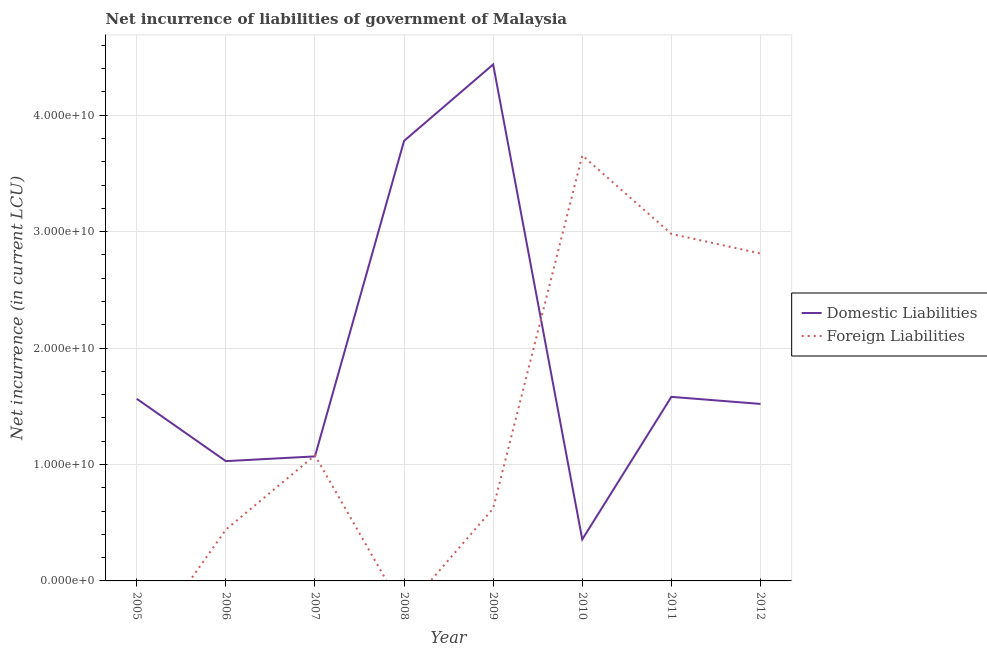How many different coloured lines are there?
Provide a succinct answer. 2. Is the number of lines equal to the number of legend labels?
Your response must be concise. No. What is the net incurrence of domestic liabilities in 2005?
Provide a short and direct response. 1.56e+1. Across all years, what is the maximum net incurrence of domestic liabilities?
Ensure brevity in your answer.  4.44e+1. Across all years, what is the minimum net incurrence of domestic liabilities?
Keep it short and to the point. 3.57e+09. What is the total net incurrence of domestic liabilities in the graph?
Ensure brevity in your answer.  1.53e+11. What is the difference between the net incurrence of domestic liabilities in 2006 and that in 2012?
Keep it short and to the point. -4.91e+09. What is the difference between the net incurrence of domestic liabilities in 2008 and the net incurrence of foreign liabilities in 2012?
Ensure brevity in your answer.  9.67e+09. What is the average net incurrence of foreign liabilities per year?
Make the answer very short. 1.45e+1. In the year 2010, what is the difference between the net incurrence of foreign liabilities and net incurrence of domestic liabilities?
Provide a short and direct response. 3.30e+1. In how many years, is the net incurrence of foreign liabilities greater than 30000000000 LCU?
Offer a terse response. 1. What is the ratio of the net incurrence of domestic liabilities in 2007 to that in 2008?
Keep it short and to the point. 0.28. Is the difference between the net incurrence of foreign liabilities in 2006 and 2012 greater than the difference between the net incurrence of domestic liabilities in 2006 and 2012?
Your response must be concise. No. What is the difference between the highest and the second highest net incurrence of foreign liabilities?
Offer a terse response. 6.74e+09. What is the difference between the highest and the lowest net incurrence of foreign liabilities?
Ensure brevity in your answer.  3.66e+1. In how many years, is the net incurrence of foreign liabilities greater than the average net incurrence of foreign liabilities taken over all years?
Make the answer very short. 3. Is the net incurrence of foreign liabilities strictly greater than the net incurrence of domestic liabilities over the years?
Keep it short and to the point. No. Is the net incurrence of domestic liabilities strictly less than the net incurrence of foreign liabilities over the years?
Your answer should be compact. No. How many lines are there?
Your response must be concise. 2. How many years are there in the graph?
Your response must be concise. 8. What is the difference between two consecutive major ticks on the Y-axis?
Provide a succinct answer. 1.00e+1. Are the values on the major ticks of Y-axis written in scientific E-notation?
Ensure brevity in your answer.  Yes. Does the graph contain grids?
Provide a succinct answer. Yes. What is the title of the graph?
Give a very brief answer. Net incurrence of liabilities of government of Malaysia. Does "Old" appear as one of the legend labels in the graph?
Offer a very short reply. No. What is the label or title of the X-axis?
Offer a terse response. Year. What is the label or title of the Y-axis?
Provide a succinct answer. Net incurrence (in current LCU). What is the Net incurrence (in current LCU) of Domestic Liabilities in 2005?
Keep it short and to the point. 1.56e+1. What is the Net incurrence (in current LCU) in Domestic Liabilities in 2006?
Provide a short and direct response. 1.03e+1. What is the Net incurrence (in current LCU) in Foreign Liabilities in 2006?
Give a very brief answer. 4.41e+09. What is the Net incurrence (in current LCU) in Domestic Liabilities in 2007?
Your response must be concise. 1.07e+1. What is the Net incurrence (in current LCU) in Foreign Liabilities in 2007?
Your answer should be very brief. 1.08e+1. What is the Net incurrence (in current LCU) in Domestic Liabilities in 2008?
Offer a terse response. 3.78e+1. What is the Net incurrence (in current LCU) of Foreign Liabilities in 2008?
Provide a succinct answer. 0. What is the Net incurrence (in current LCU) of Domestic Liabilities in 2009?
Ensure brevity in your answer.  4.44e+1. What is the Net incurrence (in current LCU) of Foreign Liabilities in 2009?
Ensure brevity in your answer.  6.23e+09. What is the Net incurrence (in current LCU) in Domestic Liabilities in 2010?
Make the answer very short. 3.57e+09. What is the Net incurrence (in current LCU) in Foreign Liabilities in 2010?
Offer a terse response. 3.66e+1. What is the Net incurrence (in current LCU) in Domestic Liabilities in 2011?
Your answer should be very brief. 1.58e+1. What is the Net incurrence (in current LCU) in Foreign Liabilities in 2011?
Provide a succinct answer. 2.98e+1. What is the Net incurrence (in current LCU) in Domestic Liabilities in 2012?
Keep it short and to the point. 1.52e+1. What is the Net incurrence (in current LCU) in Foreign Liabilities in 2012?
Ensure brevity in your answer.  2.81e+1. Across all years, what is the maximum Net incurrence (in current LCU) of Domestic Liabilities?
Provide a short and direct response. 4.44e+1. Across all years, what is the maximum Net incurrence (in current LCU) of Foreign Liabilities?
Your answer should be compact. 3.66e+1. Across all years, what is the minimum Net incurrence (in current LCU) in Domestic Liabilities?
Your response must be concise. 3.57e+09. Across all years, what is the minimum Net incurrence (in current LCU) in Foreign Liabilities?
Provide a succinct answer. 0. What is the total Net incurrence (in current LCU) in Domestic Liabilities in the graph?
Your answer should be very brief. 1.53e+11. What is the total Net incurrence (in current LCU) of Foreign Liabilities in the graph?
Give a very brief answer. 1.16e+11. What is the difference between the Net incurrence (in current LCU) in Domestic Liabilities in 2005 and that in 2006?
Offer a terse response. 5.36e+09. What is the difference between the Net incurrence (in current LCU) of Domestic Liabilities in 2005 and that in 2007?
Your answer should be compact. 4.95e+09. What is the difference between the Net incurrence (in current LCU) in Domestic Liabilities in 2005 and that in 2008?
Offer a terse response. -2.22e+1. What is the difference between the Net incurrence (in current LCU) in Domestic Liabilities in 2005 and that in 2009?
Provide a short and direct response. -2.87e+1. What is the difference between the Net incurrence (in current LCU) in Domestic Liabilities in 2005 and that in 2010?
Offer a very short reply. 1.21e+1. What is the difference between the Net incurrence (in current LCU) of Domestic Liabilities in 2005 and that in 2011?
Provide a succinct answer. -1.64e+08. What is the difference between the Net incurrence (in current LCU) of Domestic Liabilities in 2005 and that in 2012?
Give a very brief answer. 4.43e+08. What is the difference between the Net incurrence (in current LCU) in Domestic Liabilities in 2006 and that in 2007?
Your answer should be very brief. -4.07e+08. What is the difference between the Net incurrence (in current LCU) in Foreign Liabilities in 2006 and that in 2007?
Offer a terse response. -6.38e+09. What is the difference between the Net incurrence (in current LCU) in Domestic Liabilities in 2006 and that in 2008?
Ensure brevity in your answer.  -2.75e+1. What is the difference between the Net incurrence (in current LCU) in Domestic Liabilities in 2006 and that in 2009?
Keep it short and to the point. -3.41e+1. What is the difference between the Net incurrence (in current LCU) of Foreign Liabilities in 2006 and that in 2009?
Provide a short and direct response. -1.82e+09. What is the difference between the Net incurrence (in current LCU) of Domestic Liabilities in 2006 and that in 2010?
Your response must be concise. 6.72e+09. What is the difference between the Net incurrence (in current LCU) in Foreign Liabilities in 2006 and that in 2010?
Offer a terse response. -3.21e+1. What is the difference between the Net incurrence (in current LCU) of Domestic Liabilities in 2006 and that in 2011?
Keep it short and to the point. -5.52e+09. What is the difference between the Net incurrence (in current LCU) in Foreign Liabilities in 2006 and that in 2011?
Provide a succinct answer. -2.54e+1. What is the difference between the Net incurrence (in current LCU) of Domestic Liabilities in 2006 and that in 2012?
Offer a very short reply. -4.91e+09. What is the difference between the Net incurrence (in current LCU) of Foreign Liabilities in 2006 and that in 2012?
Your response must be concise. -2.37e+1. What is the difference between the Net incurrence (in current LCU) in Domestic Liabilities in 2007 and that in 2008?
Make the answer very short. -2.71e+1. What is the difference between the Net incurrence (in current LCU) in Domestic Liabilities in 2007 and that in 2009?
Make the answer very short. -3.37e+1. What is the difference between the Net incurrence (in current LCU) in Foreign Liabilities in 2007 and that in 2009?
Ensure brevity in your answer.  4.56e+09. What is the difference between the Net incurrence (in current LCU) of Domestic Liabilities in 2007 and that in 2010?
Give a very brief answer. 7.13e+09. What is the difference between the Net incurrence (in current LCU) of Foreign Liabilities in 2007 and that in 2010?
Your response must be concise. -2.58e+1. What is the difference between the Net incurrence (in current LCU) of Domestic Liabilities in 2007 and that in 2011?
Your response must be concise. -5.11e+09. What is the difference between the Net incurrence (in current LCU) of Foreign Liabilities in 2007 and that in 2011?
Ensure brevity in your answer.  -1.90e+1. What is the difference between the Net incurrence (in current LCU) in Domestic Liabilities in 2007 and that in 2012?
Your response must be concise. -4.51e+09. What is the difference between the Net incurrence (in current LCU) of Foreign Liabilities in 2007 and that in 2012?
Provide a succinct answer. -1.73e+1. What is the difference between the Net incurrence (in current LCU) in Domestic Liabilities in 2008 and that in 2009?
Provide a succinct answer. -6.57e+09. What is the difference between the Net incurrence (in current LCU) of Domestic Liabilities in 2008 and that in 2010?
Keep it short and to the point. 3.42e+1. What is the difference between the Net incurrence (in current LCU) in Domestic Liabilities in 2008 and that in 2011?
Give a very brief answer. 2.20e+1. What is the difference between the Net incurrence (in current LCU) in Domestic Liabilities in 2008 and that in 2012?
Give a very brief answer. 2.26e+1. What is the difference between the Net incurrence (in current LCU) of Domestic Liabilities in 2009 and that in 2010?
Provide a succinct answer. 4.08e+1. What is the difference between the Net incurrence (in current LCU) of Foreign Liabilities in 2009 and that in 2010?
Offer a very short reply. -3.03e+1. What is the difference between the Net incurrence (in current LCU) in Domestic Liabilities in 2009 and that in 2011?
Keep it short and to the point. 2.86e+1. What is the difference between the Net incurrence (in current LCU) in Foreign Liabilities in 2009 and that in 2011?
Make the answer very short. -2.36e+1. What is the difference between the Net incurrence (in current LCU) of Domestic Liabilities in 2009 and that in 2012?
Your response must be concise. 2.92e+1. What is the difference between the Net incurrence (in current LCU) in Foreign Liabilities in 2009 and that in 2012?
Offer a terse response. -2.19e+1. What is the difference between the Net incurrence (in current LCU) of Domestic Liabilities in 2010 and that in 2011?
Ensure brevity in your answer.  -1.22e+1. What is the difference between the Net incurrence (in current LCU) of Foreign Liabilities in 2010 and that in 2011?
Ensure brevity in your answer.  6.74e+09. What is the difference between the Net incurrence (in current LCU) of Domestic Liabilities in 2010 and that in 2012?
Make the answer very short. -1.16e+1. What is the difference between the Net incurrence (in current LCU) of Foreign Liabilities in 2010 and that in 2012?
Provide a succinct answer. 8.43e+09. What is the difference between the Net incurrence (in current LCU) of Domestic Liabilities in 2011 and that in 2012?
Your answer should be very brief. 6.07e+08. What is the difference between the Net incurrence (in current LCU) in Foreign Liabilities in 2011 and that in 2012?
Offer a terse response. 1.68e+09. What is the difference between the Net incurrence (in current LCU) of Domestic Liabilities in 2005 and the Net incurrence (in current LCU) of Foreign Liabilities in 2006?
Provide a succinct answer. 1.12e+1. What is the difference between the Net incurrence (in current LCU) in Domestic Liabilities in 2005 and the Net incurrence (in current LCU) in Foreign Liabilities in 2007?
Make the answer very short. 4.86e+09. What is the difference between the Net incurrence (in current LCU) in Domestic Liabilities in 2005 and the Net incurrence (in current LCU) in Foreign Liabilities in 2009?
Keep it short and to the point. 9.42e+09. What is the difference between the Net incurrence (in current LCU) in Domestic Liabilities in 2005 and the Net incurrence (in current LCU) in Foreign Liabilities in 2010?
Give a very brief answer. -2.09e+1. What is the difference between the Net incurrence (in current LCU) in Domestic Liabilities in 2005 and the Net incurrence (in current LCU) in Foreign Liabilities in 2011?
Give a very brief answer. -1.42e+1. What is the difference between the Net incurrence (in current LCU) of Domestic Liabilities in 2005 and the Net incurrence (in current LCU) of Foreign Liabilities in 2012?
Keep it short and to the point. -1.25e+1. What is the difference between the Net incurrence (in current LCU) of Domestic Liabilities in 2006 and the Net incurrence (in current LCU) of Foreign Liabilities in 2007?
Offer a terse response. -4.99e+08. What is the difference between the Net incurrence (in current LCU) of Domestic Liabilities in 2006 and the Net incurrence (in current LCU) of Foreign Liabilities in 2009?
Ensure brevity in your answer.  4.06e+09. What is the difference between the Net incurrence (in current LCU) in Domestic Liabilities in 2006 and the Net incurrence (in current LCU) in Foreign Liabilities in 2010?
Your response must be concise. -2.63e+1. What is the difference between the Net incurrence (in current LCU) of Domestic Liabilities in 2006 and the Net incurrence (in current LCU) of Foreign Liabilities in 2011?
Your answer should be compact. -1.95e+1. What is the difference between the Net incurrence (in current LCU) in Domestic Liabilities in 2006 and the Net incurrence (in current LCU) in Foreign Liabilities in 2012?
Your answer should be compact. -1.78e+1. What is the difference between the Net incurrence (in current LCU) of Domestic Liabilities in 2007 and the Net incurrence (in current LCU) of Foreign Liabilities in 2009?
Offer a terse response. 4.47e+09. What is the difference between the Net incurrence (in current LCU) in Domestic Liabilities in 2007 and the Net incurrence (in current LCU) in Foreign Liabilities in 2010?
Ensure brevity in your answer.  -2.59e+1. What is the difference between the Net incurrence (in current LCU) of Domestic Liabilities in 2007 and the Net incurrence (in current LCU) of Foreign Liabilities in 2011?
Ensure brevity in your answer.  -1.91e+1. What is the difference between the Net incurrence (in current LCU) in Domestic Liabilities in 2007 and the Net incurrence (in current LCU) in Foreign Liabilities in 2012?
Keep it short and to the point. -1.74e+1. What is the difference between the Net incurrence (in current LCU) of Domestic Liabilities in 2008 and the Net incurrence (in current LCU) of Foreign Liabilities in 2009?
Give a very brief answer. 3.16e+1. What is the difference between the Net incurrence (in current LCU) in Domestic Liabilities in 2008 and the Net incurrence (in current LCU) in Foreign Liabilities in 2010?
Ensure brevity in your answer.  1.25e+09. What is the difference between the Net incurrence (in current LCU) in Domestic Liabilities in 2008 and the Net incurrence (in current LCU) in Foreign Liabilities in 2011?
Offer a terse response. 7.99e+09. What is the difference between the Net incurrence (in current LCU) of Domestic Liabilities in 2008 and the Net incurrence (in current LCU) of Foreign Liabilities in 2012?
Give a very brief answer. 9.67e+09. What is the difference between the Net incurrence (in current LCU) in Domestic Liabilities in 2009 and the Net incurrence (in current LCU) in Foreign Liabilities in 2010?
Offer a terse response. 7.81e+09. What is the difference between the Net incurrence (in current LCU) in Domestic Liabilities in 2009 and the Net incurrence (in current LCU) in Foreign Liabilities in 2011?
Your answer should be very brief. 1.46e+1. What is the difference between the Net incurrence (in current LCU) of Domestic Liabilities in 2009 and the Net incurrence (in current LCU) of Foreign Liabilities in 2012?
Your answer should be very brief. 1.62e+1. What is the difference between the Net incurrence (in current LCU) of Domestic Liabilities in 2010 and the Net incurrence (in current LCU) of Foreign Liabilities in 2011?
Ensure brevity in your answer.  -2.62e+1. What is the difference between the Net incurrence (in current LCU) in Domestic Liabilities in 2010 and the Net incurrence (in current LCU) in Foreign Liabilities in 2012?
Keep it short and to the point. -2.46e+1. What is the difference between the Net incurrence (in current LCU) in Domestic Liabilities in 2011 and the Net incurrence (in current LCU) in Foreign Liabilities in 2012?
Offer a terse response. -1.23e+1. What is the average Net incurrence (in current LCU) of Domestic Liabilities per year?
Provide a succinct answer. 1.92e+1. What is the average Net incurrence (in current LCU) in Foreign Liabilities per year?
Provide a short and direct response. 1.45e+1. In the year 2006, what is the difference between the Net incurrence (in current LCU) of Domestic Liabilities and Net incurrence (in current LCU) of Foreign Liabilities?
Your answer should be very brief. 5.88e+09. In the year 2007, what is the difference between the Net incurrence (in current LCU) of Domestic Liabilities and Net incurrence (in current LCU) of Foreign Liabilities?
Your answer should be very brief. -9.14e+07. In the year 2009, what is the difference between the Net incurrence (in current LCU) in Domestic Liabilities and Net incurrence (in current LCU) in Foreign Liabilities?
Your response must be concise. 3.81e+1. In the year 2010, what is the difference between the Net incurrence (in current LCU) of Domestic Liabilities and Net incurrence (in current LCU) of Foreign Liabilities?
Offer a very short reply. -3.30e+1. In the year 2011, what is the difference between the Net incurrence (in current LCU) in Domestic Liabilities and Net incurrence (in current LCU) in Foreign Liabilities?
Keep it short and to the point. -1.40e+1. In the year 2012, what is the difference between the Net incurrence (in current LCU) in Domestic Liabilities and Net incurrence (in current LCU) in Foreign Liabilities?
Offer a very short reply. -1.29e+1. What is the ratio of the Net incurrence (in current LCU) of Domestic Liabilities in 2005 to that in 2006?
Offer a terse response. 1.52. What is the ratio of the Net incurrence (in current LCU) of Domestic Liabilities in 2005 to that in 2007?
Provide a short and direct response. 1.46. What is the ratio of the Net incurrence (in current LCU) in Domestic Liabilities in 2005 to that in 2008?
Provide a succinct answer. 0.41. What is the ratio of the Net incurrence (in current LCU) in Domestic Liabilities in 2005 to that in 2009?
Offer a very short reply. 0.35. What is the ratio of the Net incurrence (in current LCU) in Domestic Liabilities in 2005 to that in 2010?
Offer a very short reply. 4.39. What is the ratio of the Net incurrence (in current LCU) of Domestic Liabilities in 2005 to that in 2011?
Give a very brief answer. 0.99. What is the ratio of the Net incurrence (in current LCU) of Domestic Liabilities in 2005 to that in 2012?
Your response must be concise. 1.03. What is the ratio of the Net incurrence (in current LCU) of Domestic Liabilities in 2006 to that in 2007?
Offer a terse response. 0.96. What is the ratio of the Net incurrence (in current LCU) in Foreign Liabilities in 2006 to that in 2007?
Ensure brevity in your answer.  0.41. What is the ratio of the Net incurrence (in current LCU) in Domestic Liabilities in 2006 to that in 2008?
Give a very brief answer. 0.27. What is the ratio of the Net incurrence (in current LCU) in Domestic Liabilities in 2006 to that in 2009?
Make the answer very short. 0.23. What is the ratio of the Net incurrence (in current LCU) in Foreign Liabilities in 2006 to that in 2009?
Ensure brevity in your answer.  0.71. What is the ratio of the Net incurrence (in current LCU) of Domestic Liabilities in 2006 to that in 2010?
Your answer should be very brief. 2.88. What is the ratio of the Net incurrence (in current LCU) in Foreign Liabilities in 2006 to that in 2010?
Offer a very short reply. 0.12. What is the ratio of the Net incurrence (in current LCU) of Domestic Liabilities in 2006 to that in 2011?
Make the answer very short. 0.65. What is the ratio of the Net incurrence (in current LCU) in Foreign Liabilities in 2006 to that in 2011?
Your answer should be very brief. 0.15. What is the ratio of the Net incurrence (in current LCU) of Domestic Liabilities in 2006 to that in 2012?
Provide a short and direct response. 0.68. What is the ratio of the Net incurrence (in current LCU) in Foreign Liabilities in 2006 to that in 2012?
Ensure brevity in your answer.  0.16. What is the ratio of the Net incurrence (in current LCU) in Domestic Liabilities in 2007 to that in 2008?
Give a very brief answer. 0.28. What is the ratio of the Net incurrence (in current LCU) in Domestic Liabilities in 2007 to that in 2009?
Your response must be concise. 0.24. What is the ratio of the Net incurrence (in current LCU) of Foreign Liabilities in 2007 to that in 2009?
Your answer should be compact. 1.73. What is the ratio of the Net incurrence (in current LCU) of Domestic Liabilities in 2007 to that in 2010?
Give a very brief answer. 3. What is the ratio of the Net incurrence (in current LCU) of Foreign Liabilities in 2007 to that in 2010?
Provide a succinct answer. 0.3. What is the ratio of the Net incurrence (in current LCU) of Domestic Liabilities in 2007 to that in 2011?
Ensure brevity in your answer.  0.68. What is the ratio of the Net incurrence (in current LCU) in Foreign Liabilities in 2007 to that in 2011?
Make the answer very short. 0.36. What is the ratio of the Net incurrence (in current LCU) in Domestic Liabilities in 2007 to that in 2012?
Your response must be concise. 0.7. What is the ratio of the Net incurrence (in current LCU) of Foreign Liabilities in 2007 to that in 2012?
Provide a succinct answer. 0.38. What is the ratio of the Net incurrence (in current LCU) of Domestic Liabilities in 2008 to that in 2009?
Provide a short and direct response. 0.85. What is the ratio of the Net incurrence (in current LCU) in Domestic Liabilities in 2008 to that in 2010?
Keep it short and to the point. 10.6. What is the ratio of the Net incurrence (in current LCU) in Domestic Liabilities in 2008 to that in 2011?
Provide a short and direct response. 2.39. What is the ratio of the Net incurrence (in current LCU) of Domestic Liabilities in 2008 to that in 2012?
Your answer should be compact. 2.49. What is the ratio of the Net incurrence (in current LCU) in Domestic Liabilities in 2009 to that in 2010?
Ensure brevity in your answer.  12.44. What is the ratio of the Net incurrence (in current LCU) of Foreign Liabilities in 2009 to that in 2010?
Offer a terse response. 0.17. What is the ratio of the Net incurrence (in current LCU) in Domestic Liabilities in 2009 to that in 2011?
Make the answer very short. 2.81. What is the ratio of the Net incurrence (in current LCU) in Foreign Liabilities in 2009 to that in 2011?
Offer a very short reply. 0.21. What is the ratio of the Net incurrence (in current LCU) of Domestic Liabilities in 2009 to that in 2012?
Your response must be concise. 2.92. What is the ratio of the Net incurrence (in current LCU) in Foreign Liabilities in 2009 to that in 2012?
Your response must be concise. 0.22. What is the ratio of the Net incurrence (in current LCU) in Domestic Liabilities in 2010 to that in 2011?
Offer a very short reply. 0.23. What is the ratio of the Net incurrence (in current LCU) of Foreign Liabilities in 2010 to that in 2011?
Ensure brevity in your answer.  1.23. What is the ratio of the Net incurrence (in current LCU) in Domestic Liabilities in 2010 to that in 2012?
Your answer should be very brief. 0.23. What is the ratio of the Net incurrence (in current LCU) in Foreign Liabilities in 2010 to that in 2012?
Keep it short and to the point. 1.3. What is the ratio of the Net incurrence (in current LCU) of Domestic Liabilities in 2011 to that in 2012?
Make the answer very short. 1.04. What is the ratio of the Net incurrence (in current LCU) of Foreign Liabilities in 2011 to that in 2012?
Offer a terse response. 1.06. What is the difference between the highest and the second highest Net incurrence (in current LCU) of Domestic Liabilities?
Offer a very short reply. 6.57e+09. What is the difference between the highest and the second highest Net incurrence (in current LCU) in Foreign Liabilities?
Give a very brief answer. 6.74e+09. What is the difference between the highest and the lowest Net incurrence (in current LCU) in Domestic Liabilities?
Give a very brief answer. 4.08e+1. What is the difference between the highest and the lowest Net incurrence (in current LCU) in Foreign Liabilities?
Offer a terse response. 3.66e+1. 